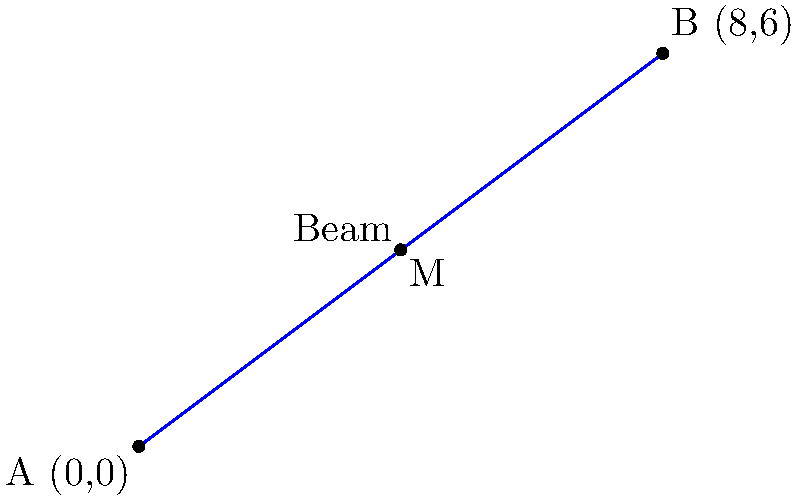You're working on a new building project, and you need to find the midpoint of a structural beam. The beam starts at point A (0,0) and ends at point B (8,6) in your blueprint's coordinate system. What are the coordinates of the midpoint M of this beam? To find the midpoint of a beam, we can use the midpoint formula:

$$ M_x = \frac{x_1 + x_2}{2}, \quad M_y = \frac{y_1 + y_2}{2} $$

Where $(x_1, y_1)$ are the coordinates of point A, and $(x_2, y_2)$ are the coordinates of point B.

Step 1: Identify the coordinates
- Point A: (0, 0)
- Point B: (8, 6)

Step 2: Calculate the x-coordinate of the midpoint
$$ M_x = \frac{0 + 8}{2} = \frac{8}{2} = 4 $$

Step 3: Calculate the y-coordinate of the midpoint
$$ M_y = \frac{0 + 6}{2} = \frac{6}{2} = 3 $$

Therefore, the midpoint M of the beam has coordinates (4, 3).
Answer: (4, 3) 